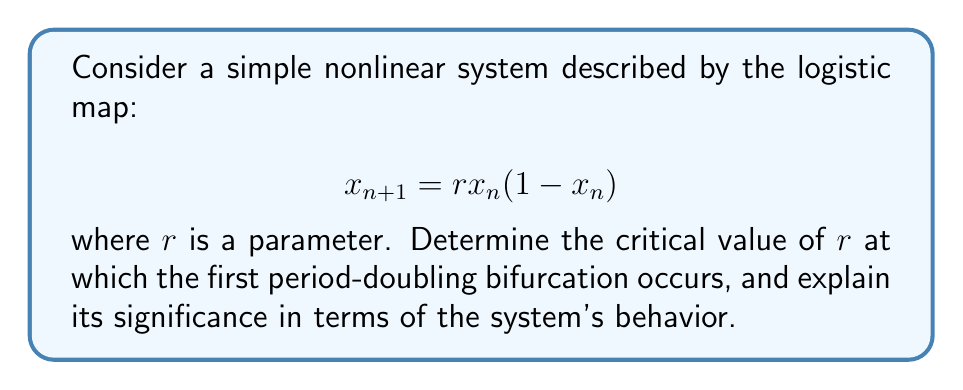Can you solve this math problem? Let's approach this step-by-step:

1) The logistic map is a discrete-time dynamical system that exhibits different behaviors depending on the parameter $r$.

2) To find fixed points, we set $x_{n+1} = x_n = x^*$:

   $$x^* = rx^*(1-x^*)$$

3) Solving this equation gives two fixed points:

   $$x^* = 0$$ and $$x^* = 1 - \frac{1}{r}$$

4) The stability of these fixed points can be determined by the derivative of the map at the fixed point:

   $$f'(x) = r(1-2x)$$

5) For the non-zero fixed point $x^* = 1 - \frac{1}{r}$, we have:

   $$f'(1-\frac{1}{r}) = r(1-2(1-\frac{1}{r})) = r(2\frac{1}{r}-1) = 2-r$$

6) The fixed point loses stability when $|f'(x^*)| = 1$. In this case:

   $$|2-r| = 1$$

7) Solving this equation:

   $$2-r = 1$$ or $$2-r = -1$$
   $$r = 1$$ or $$r = 3$$

8) The first period-doubling bifurcation occurs at $r = 3$.

9) This bifurcation is significant because it marks the transition from a stable fixed point to a stable 2-cycle. For $1 < r < 3$, the system converges to a single fixed point. For $3 < r < 1+\sqrt{6}$, the system alternates between two values.

10) This is the beginning of the period-doubling cascade, which eventually leads to chaos as $r$ increases further.
Answer: $r = 3$ 